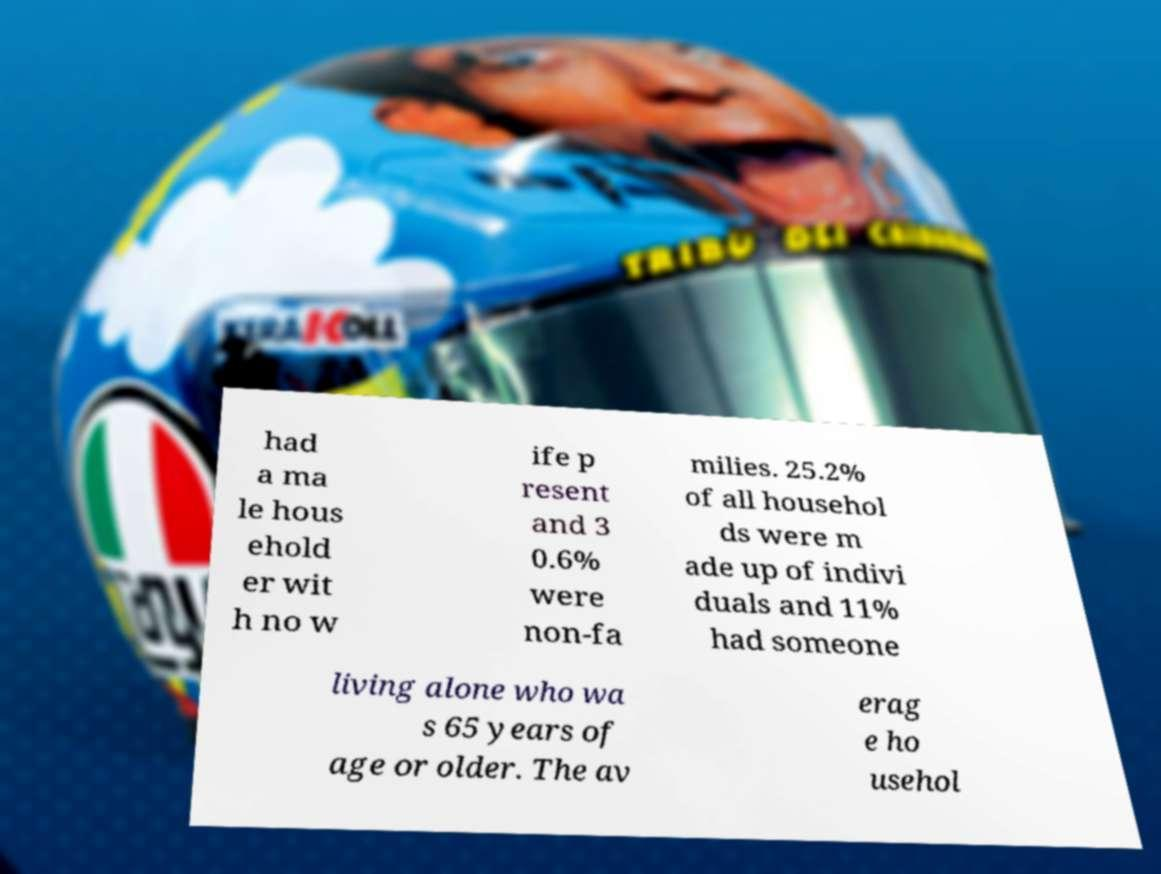There's text embedded in this image that I need extracted. Can you transcribe it verbatim? had a ma le hous ehold er wit h no w ife p resent and 3 0.6% were non-fa milies. 25.2% of all househol ds were m ade up of indivi duals and 11% had someone living alone who wa s 65 years of age or older. The av erag e ho usehol 